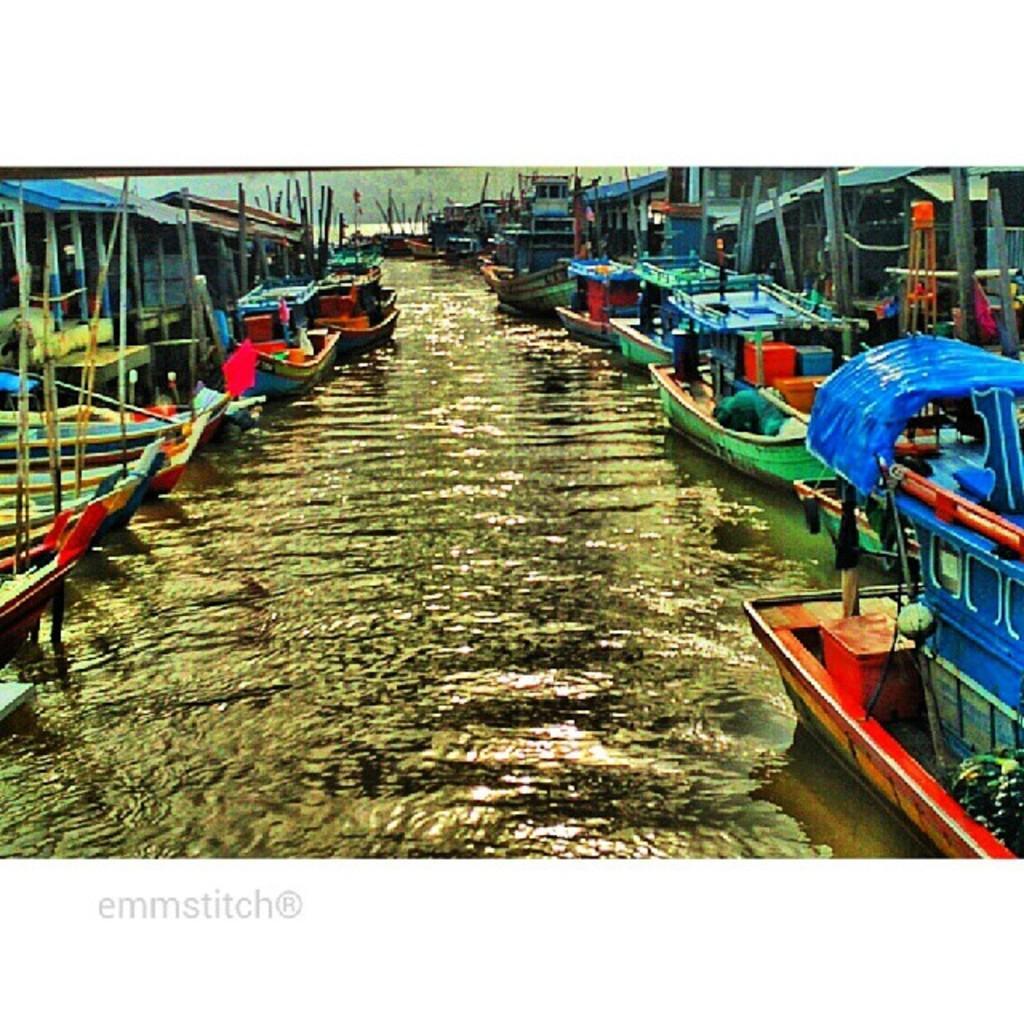Can you describe this image briefly? In the picture we can see water and on the either side of the water we can see boats and in the background we can see some boats and trees. 